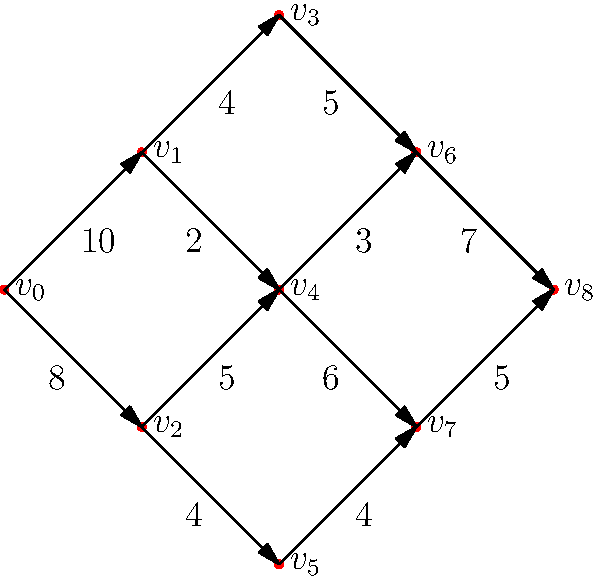Derek Carr wants to optimize his passing routes to different receivers. The directed graph above represents possible passing routes, where $v_0$ is Carr's starting position, $v_1$ to $v_7$ are intermediate positions or receivers, and $v_8$ is the end zone. The edge weights represent the maximum number of successful passes (in hundreds) that can be completed along that route in a season. What is the maximum flow (total number of successful passes in hundreds) from $v_0$ to $v_8$? To solve this maximum flow problem, we'll use the Ford-Fulkerson algorithm:

1) Initialize flow to 0.

2) Find an augmenting path from $v_0$ to $v_8$:
   Path 1: $v_0 \rightarrow v_1 \rightarrow v_3 \rightarrow v_6 \rightarrow v_8$ (min capacity 4)
   Flow = 4, Residual capacities updated.

3) Find another augmenting path:
   Path 2: $v_0 \rightarrow v_2 \rightarrow v_4 \rightarrow v_6 \rightarrow v_8$ (min capacity 3)
   Flow = 4 + 3 = 7, Residual capacities updated.

4) Find another augmenting path:
   Path 3: $v_0 \rightarrow v_2 \rightarrow v_4 \rightarrow v_7 \rightarrow v_8$ (min capacity 5)
   Flow = 7 + 5 = 12, Residual capacities updated.

5) No more augmenting paths exist.

Therefore, the maximum flow is 12, representing 1200 successful passes in a season.
Answer: 12 (representing 1200 passes) 